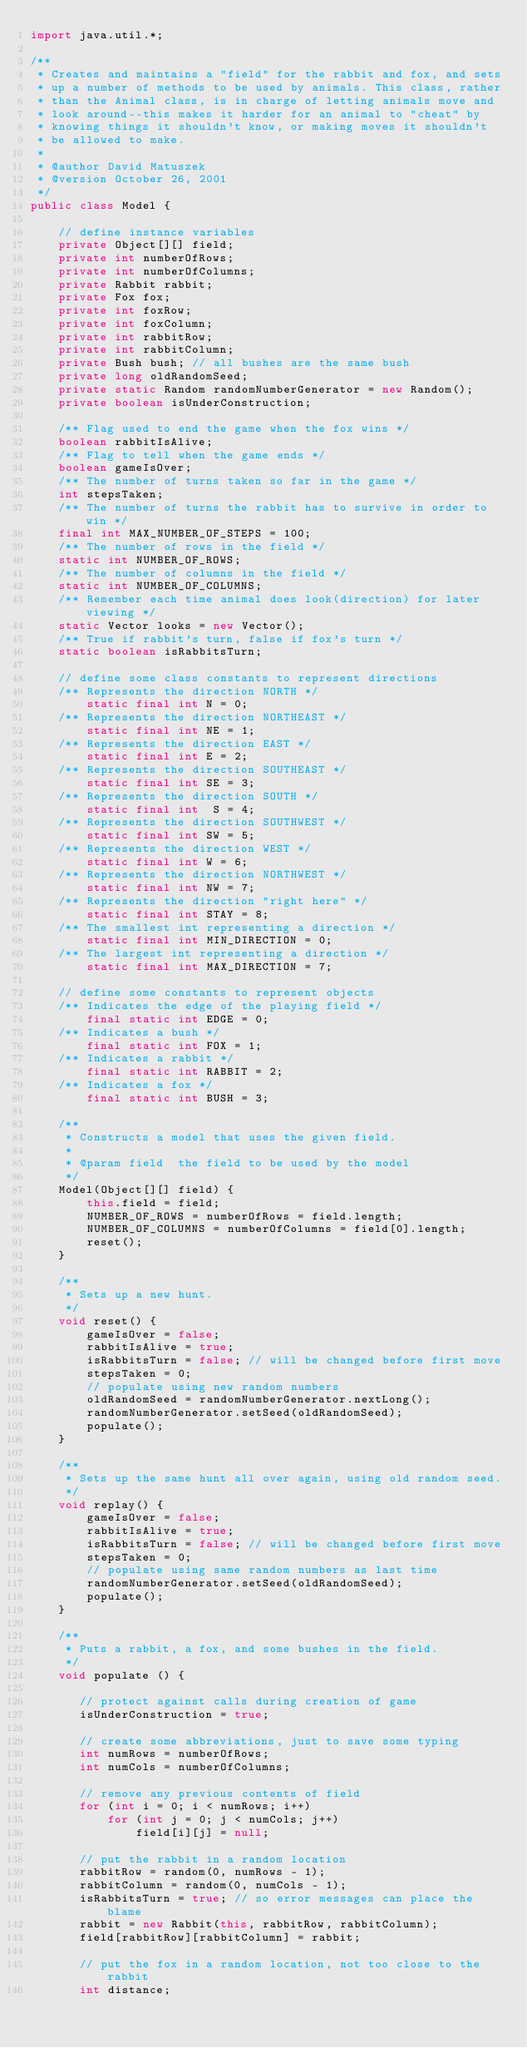Convert code to text. <code><loc_0><loc_0><loc_500><loc_500><_Java_>import java.util.*;

/**
 * Creates and maintains a "field" for the rabbit and fox, and sets
 * up a number of methods to be used by animals. This class, rather
 * than the Animal class, is in charge of letting animals move and
 * look around--this makes it harder for an animal to "cheat" by
 * knowing things it shouldn't know, or making moves it shouldn't
 * be allowed to make.
 * 
 * @author David Matuszek 
 * @version October 26, 2001
 */
public class Model {
    
    // define instance variables
    private Object[][] field;
    private int numberOfRows;
    private int numberOfColumns;
    private Rabbit rabbit;
    private Fox fox;
    private int foxRow;
    private int foxColumn;
    private int rabbitRow;
    private int rabbitColumn;
    private Bush bush; // all bushes are the same bush
    private long oldRandomSeed;
    private static Random randomNumberGenerator = new Random();
    private boolean isUnderConstruction;
    
    /** Flag used to end the game when the fox wins */
    boolean rabbitIsAlive;
    /** Flag to tell when the game ends */
    boolean gameIsOver;
    /** The number of turns taken so far in the game */
    int stepsTaken;
    /** The number of turns the rabbit has to survive in order to win */
    final int MAX_NUMBER_OF_STEPS = 100;
    /** The number of rows in the field */
    static int NUMBER_OF_ROWS;
    /** The number of columns in the field */
    static int NUMBER_OF_COLUMNS;
    /** Remember each time animal does look(direction) for later viewing */
    static Vector looks = new Vector();
    /** True if rabbit's turn, false if fox's turn */
    static boolean isRabbitsTurn;

    // define some class constants to represent directions
    /** Represents the direction NORTH */
        static final int N = 0;
    /** Represents the direction NORTHEAST */
        static final int NE = 1;
    /** Represents the direction EAST */
        static final int E = 2;
    /** Represents the direction SOUTHEAST */
        static final int SE = 3;
    /** Represents the direction SOUTH */
        static final int  S = 4;
    /** Represents the direction SOUTHWEST */
        static final int SW = 5;
    /** Represents the direction WEST */
        static final int W = 6;
    /** Represents the direction NORTHWEST */
        static final int NW = 7;
    /** Represents the direction "right here" */
        static final int STAY = 8;
    /** The smallest int representing a direction */
        static final int MIN_DIRECTION = 0;
    /** The largest int representing a direction */
        static final int MAX_DIRECTION = 7;

    // define some constants to represent objects
    /** Indicates the edge of the playing field */
        final static int EDGE = 0;
    /** Indicates a bush */
        final static int FOX = 1;
    /** Indicates a rabbit */
        final static int RABBIT = 2;
    /** Indicates a fox */
        final static int BUSH = 3;
    
    /**
     * Constructs a model that uses the given field.
     *
     * @param field  the field to be used by the model
     */
    Model(Object[][] field) {
        this.field = field;
        NUMBER_OF_ROWS = numberOfRows = field.length;
        NUMBER_OF_COLUMNS = numberOfColumns = field[0].length;
        reset();
    }
    
    /**
     * Sets up a new hunt.
     */
    void reset() {
        gameIsOver = false;
        rabbitIsAlive = true;
        isRabbitsTurn = false; // will be changed before first move
        stepsTaken = 0;
        // populate using new random numbers
        oldRandomSeed = randomNumberGenerator.nextLong();
        randomNumberGenerator.setSeed(oldRandomSeed);
        populate();
    }
    
    /**
     * Sets up the same hunt all over again, using old random seed.
     */
    void replay() {
        gameIsOver = false;
        rabbitIsAlive = true;
        isRabbitsTurn = false; // will be changed before first move
        stepsTaken = 0;
        // populate using same random numbers as last time
        randomNumberGenerator.setSeed(oldRandomSeed);
        populate();
    }

    /**
     * Puts a rabbit, a fox, and some bushes in the field.
     */
    void populate () {
    
       // protect against calls during creation of game
       isUnderConstruction = true;
       
       // create some abbreviations, just to save some typing
       int numRows = numberOfRows;
       int numCols = numberOfColumns;
       
       // remove any previous contents of field
       for (int i = 0; i < numRows; i++)
           for (int j = 0; j < numCols; j++)
               field[i][j] = null;
       
       // put the rabbit in a random location
       rabbitRow = random(0, numRows - 1);
       rabbitColumn = random(0, numCols - 1);
       isRabbitsTurn = true; // so error messages can place the blame
       rabbit = new Rabbit(this, rabbitRow, rabbitColumn);
       field[rabbitRow][rabbitColumn] = rabbit;
       
       // put the fox in a random location, not too close to the rabbit
       int distance;</code> 